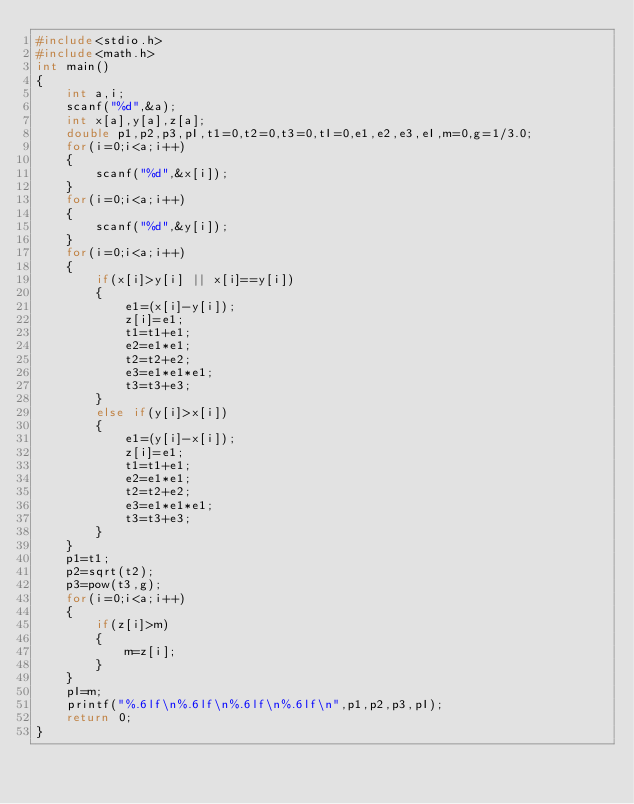Convert code to text. <code><loc_0><loc_0><loc_500><loc_500><_C_>#include<stdio.h>
#include<math.h>
int main()
{
    int a,i;
    scanf("%d",&a);
    int x[a],y[a],z[a];
    double p1,p2,p3,pI,t1=0,t2=0,t3=0,tI=0,e1,e2,e3,eI,m=0,g=1/3.0;
    for(i=0;i<a;i++)
    {
        scanf("%d",&x[i]);
    }
    for(i=0;i<a;i++)
    {
        scanf("%d",&y[i]);
    }
    for(i=0;i<a;i++)
    {
        if(x[i]>y[i] || x[i]==y[i])
        {
            e1=(x[i]-y[i]);
            z[i]=e1;
            t1=t1+e1;
            e2=e1*e1;
            t2=t2+e2;
            e3=e1*e1*e1;
            t3=t3+e3;
        }
        else if(y[i]>x[i])
        {
            e1=(y[i]-x[i]);
            z[i]=e1;
            t1=t1+e1;
            e2=e1*e1;
            t2=t2+e2;
            e3=e1*e1*e1;
            t3=t3+e3;
        }
    }
    p1=t1;
    p2=sqrt(t2);
    p3=pow(t3,g);
    for(i=0;i<a;i++)
    {
        if(z[i]>m)
        {
            m=z[i];
        }
    }
    pI=m;
    printf("%.6lf\n%.6lf\n%.6lf\n%.6lf\n",p1,p2,p3,pI);
    return 0;
}
</code> 